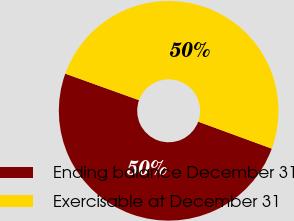<chart> <loc_0><loc_0><loc_500><loc_500><pie_chart><fcel>Ending balance December 31<fcel>Exercisable at December 31<nl><fcel>49.9%<fcel>50.1%<nl></chart> 